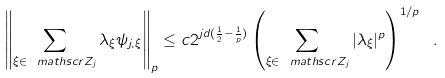Convert formula to latex. <formula><loc_0><loc_0><loc_500><loc_500>\left \| \sum _ { \xi \in \ m a t h s c r { Z } _ { j } } \lambda _ { \xi } \psi _ { j , \xi } \right \| _ { p } \leq c 2 ^ { j d ( \frac { 1 } { 2 } - \frac { 1 } { p } ) } \left ( \sum _ { \xi \in \ m a t h s c r { Z } _ { j } } | \lambda _ { \xi } | ^ { p } \right ) ^ { 1 / p } \ .</formula> 